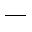<formula> <loc_0><loc_0><loc_500><loc_500>\_</formula> 